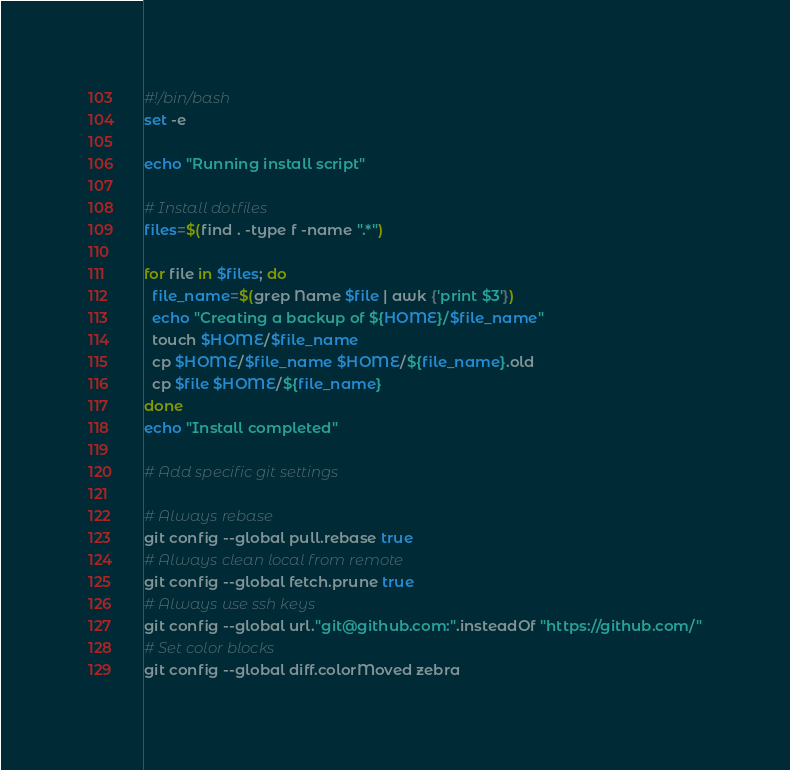Convert code to text. <code><loc_0><loc_0><loc_500><loc_500><_Bash_>#!/bin/bash
set -e

echo "Running install script"

# Install dotfiles
files=$(find . -type f -name ".*")

for file in $files; do
  file_name=$(grep Name $file | awk {'print $3'})
  echo "Creating a backup of ${HOME}/$file_name"
  touch $HOME/$file_name
  cp $HOME/$file_name $HOME/${file_name}.old
  cp $file $HOME/${file_name}
done
echo "Install completed"

# Add specific git settings

# Always rebase
git config --global pull.rebase true
# Always clean local from remote
git config --global fetch.prune true
# Always use ssh keys
git config --global url."git@github.com:".insteadOf "https://github.com/"
# Set color blocks
git config --global diff.colorMoved zebra

</code> 